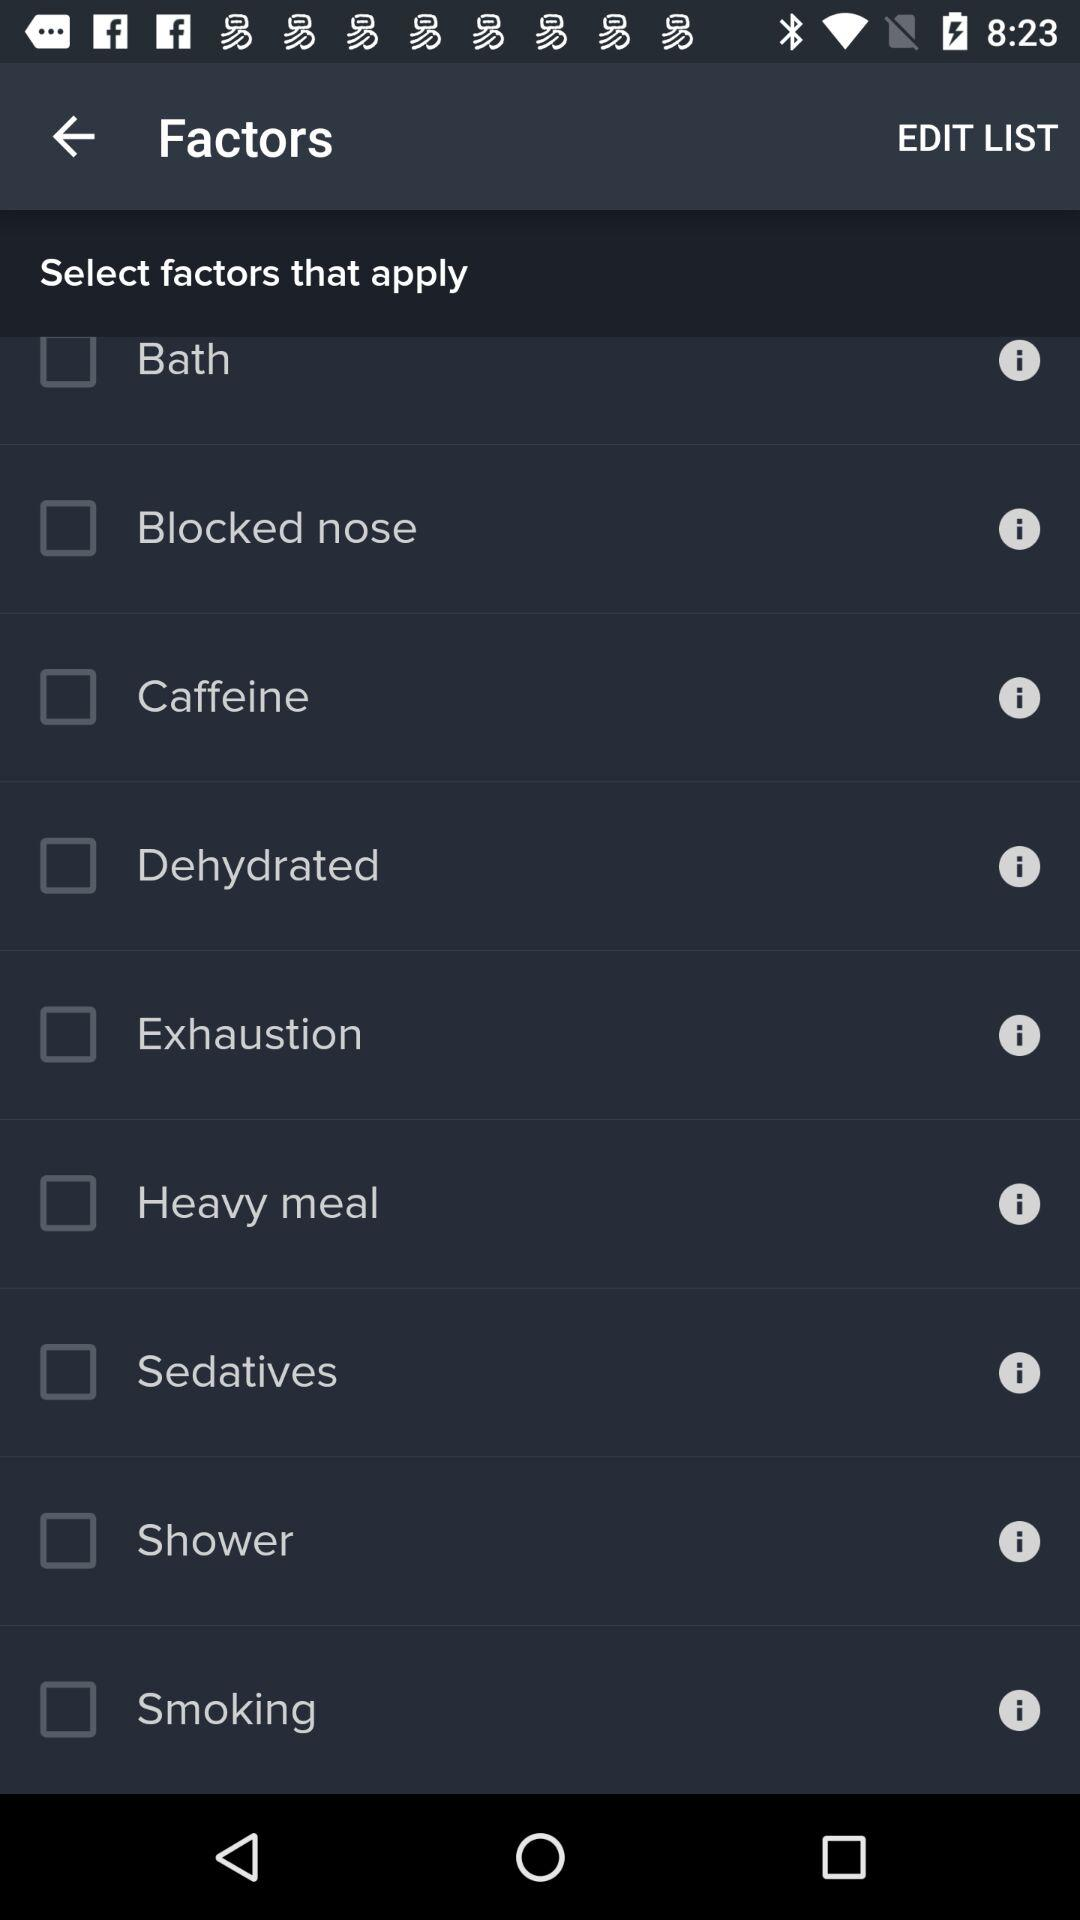What is the status of "Caffeine"? The status is "off". 